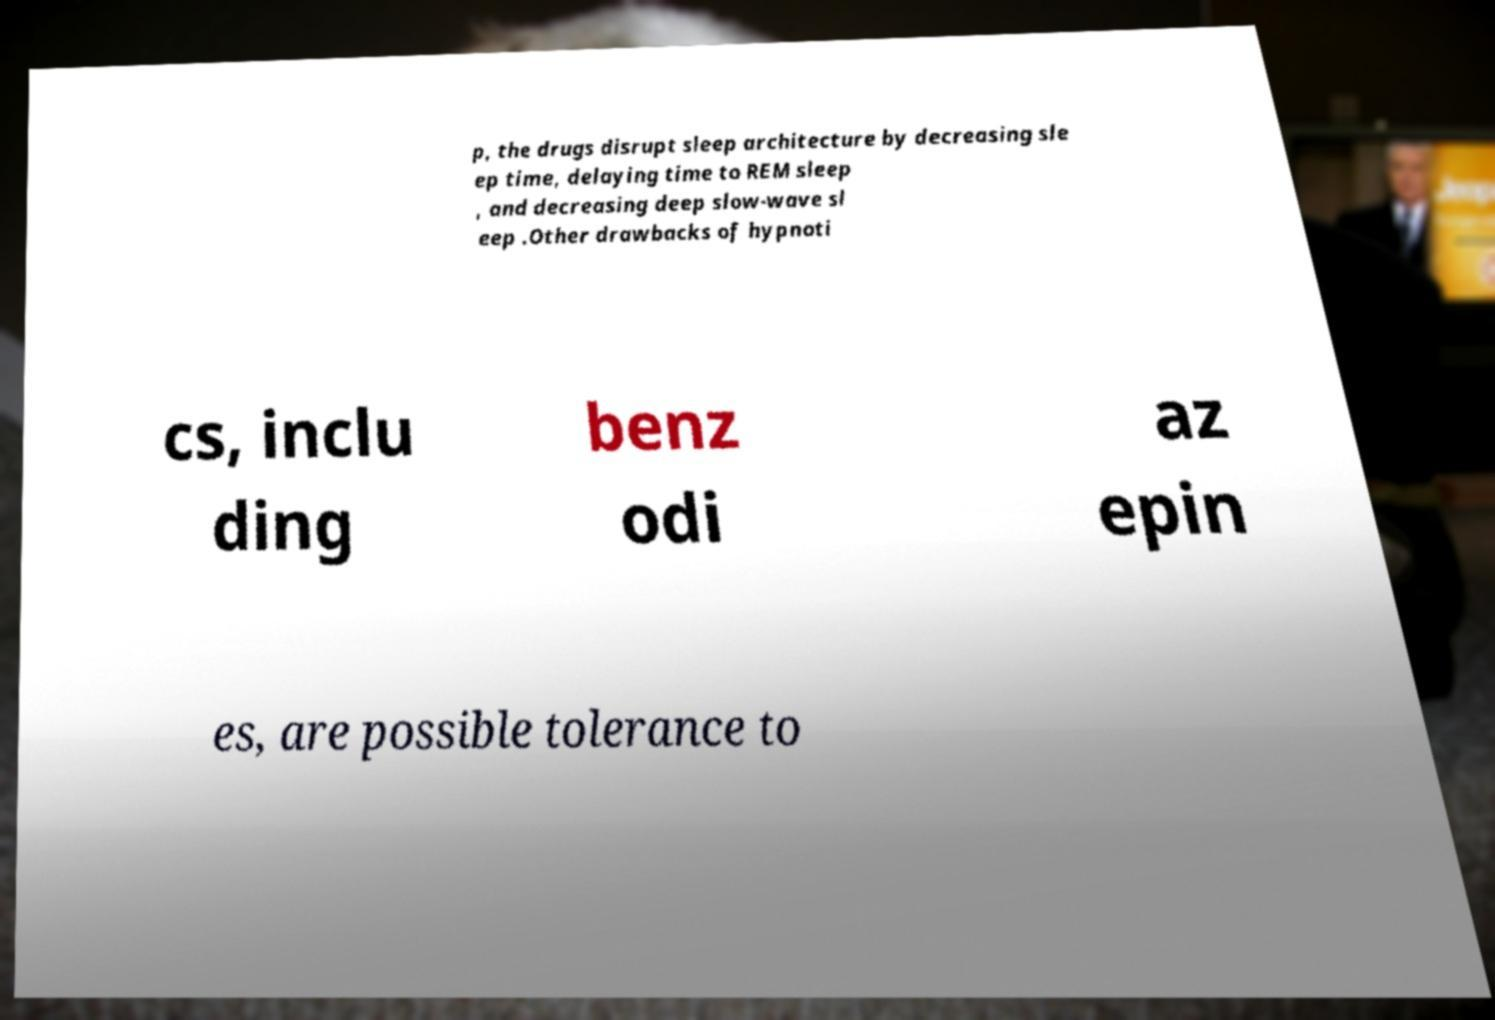There's text embedded in this image that I need extracted. Can you transcribe it verbatim? p, the drugs disrupt sleep architecture by decreasing sle ep time, delaying time to REM sleep , and decreasing deep slow-wave sl eep .Other drawbacks of hypnoti cs, inclu ding benz odi az epin es, are possible tolerance to 